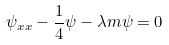Convert formula to latex. <formula><loc_0><loc_0><loc_500><loc_500>\psi _ { x x } - \frac { 1 } { 4 } \psi - \lambda m \psi = 0</formula> 